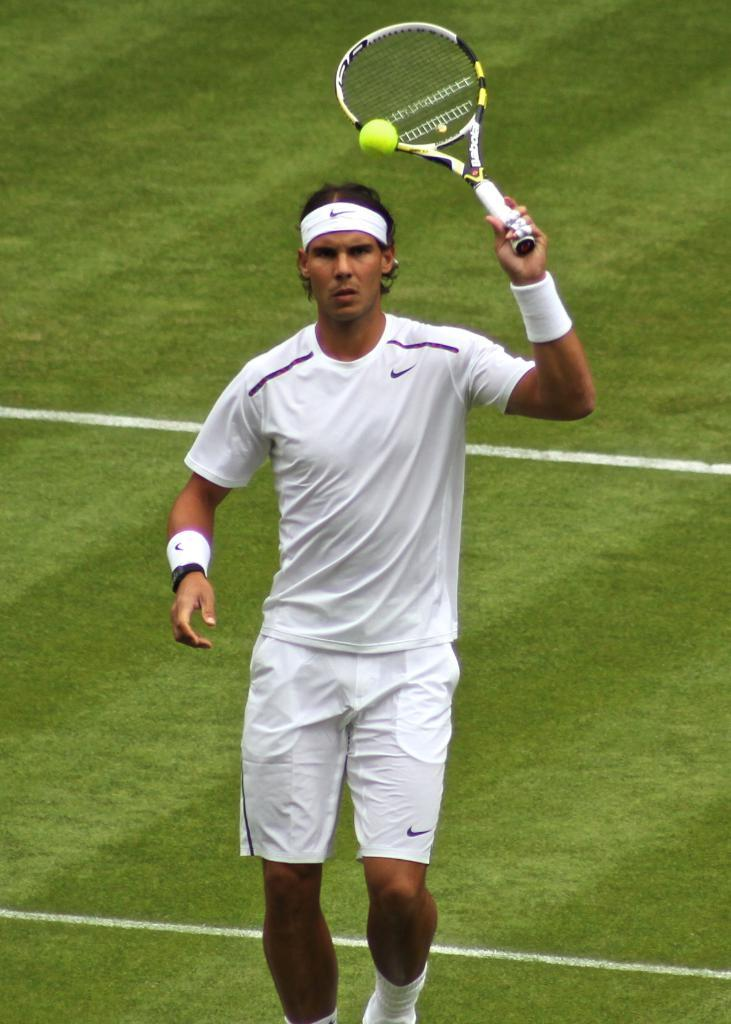What is the man in the image doing? The man is standing in the image and holding a racket. What might the man be playing in the image? The presence of a racket suggests that the man might be playing a racket sport, such as tennis or badminton. What can be seen in the background of the image? There is grass in the background of the image. What type of memory can be seen in the image? There is no memory present in the image; it features a man holding a racket and grass in the background. Can you tell me how many cans are visible in the image? There are no cans present in the image. 